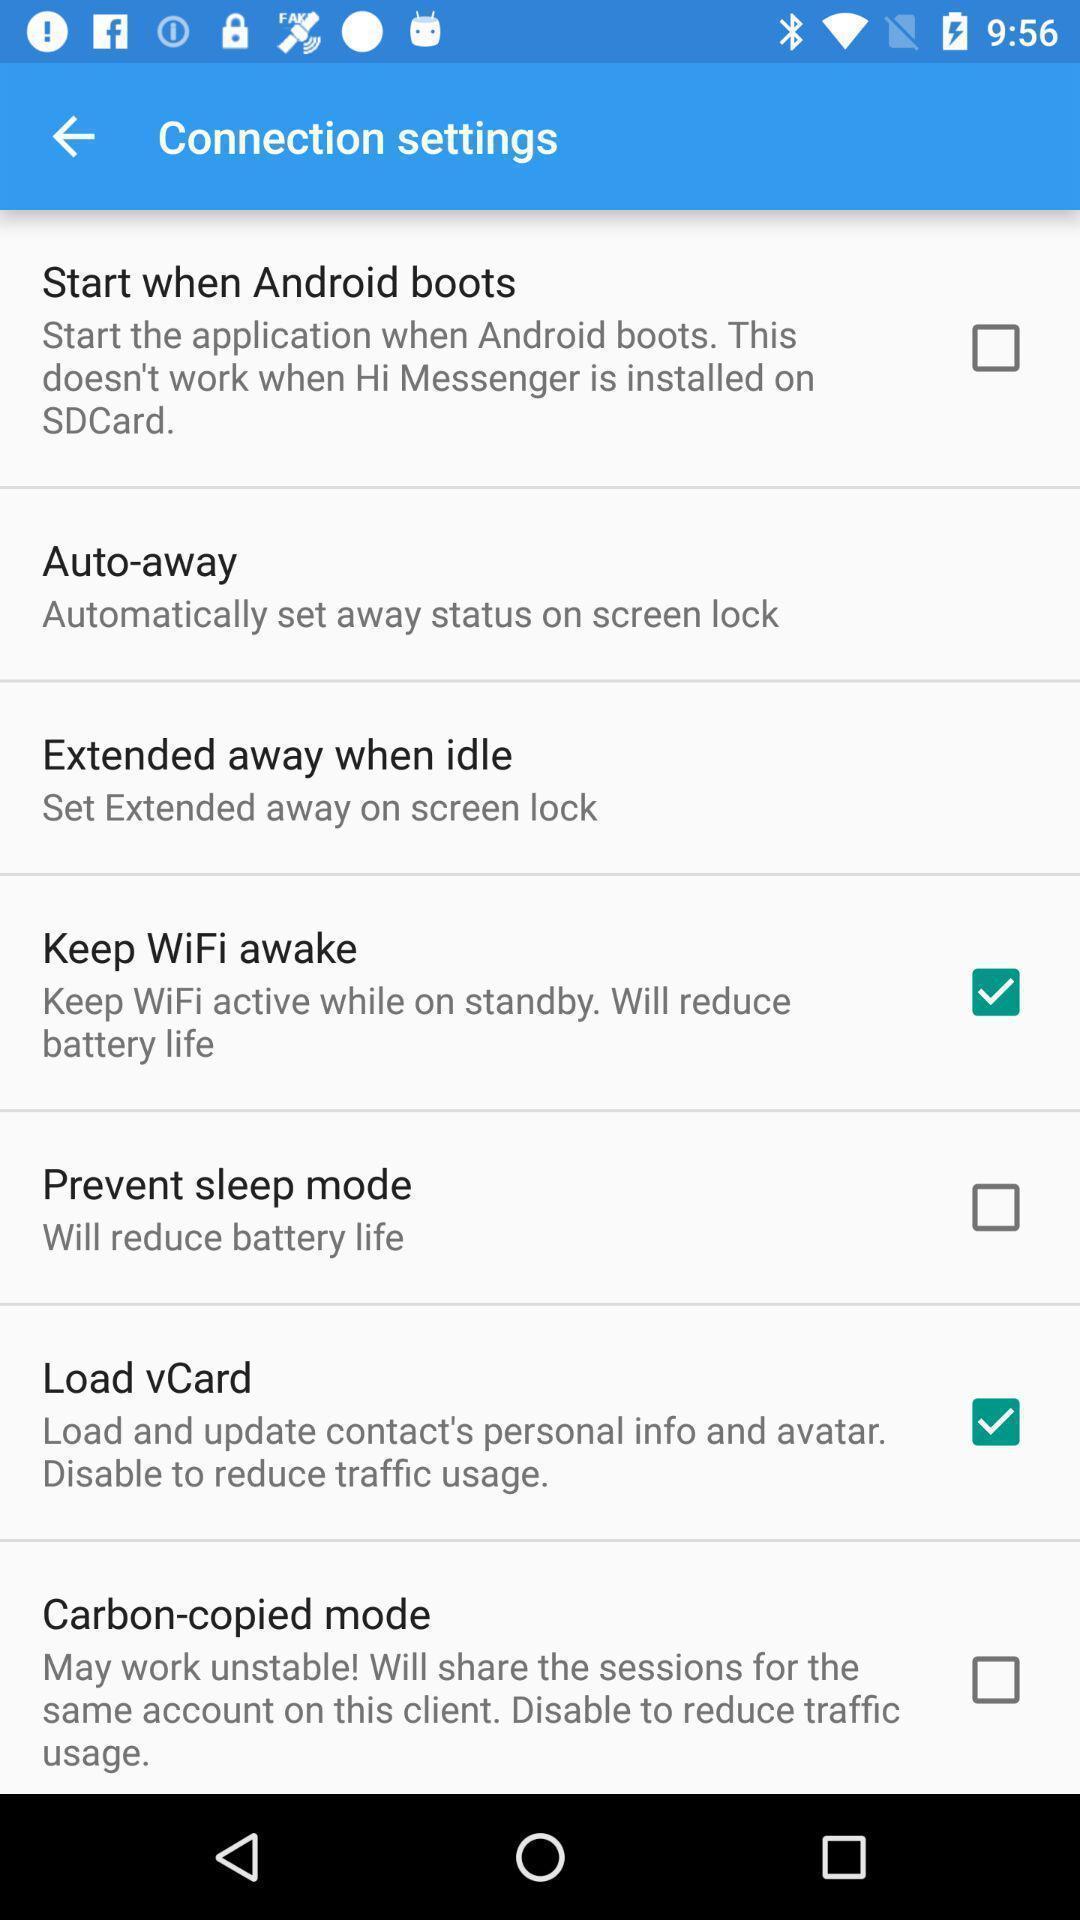Explain the elements present in this screenshot. Setting page displaying the various options. 